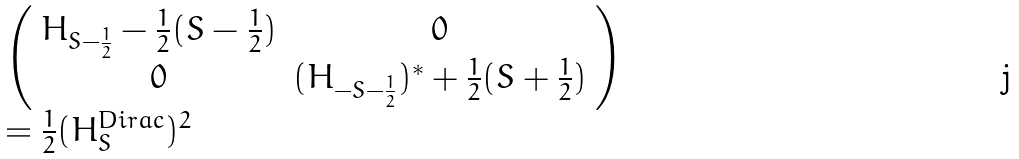<formula> <loc_0><loc_0><loc_500><loc_500>\begin{array} { l } \left ( \begin{array} { c c } H _ { S - \frac { 1 } { 2 } } - \frac { 1 } { 2 } ( S - \frac { 1 } { 2 } ) & 0 \\ 0 & ( H _ { - S - \frac { 1 } { 2 } } ) ^ { * } + \frac { 1 } { 2 } ( S + \frac { 1 } { 2 } ) \end{array} \right ) \ \\ = \frac { 1 } { 2 } ( H ^ { D i r a c } _ { S } ) ^ { 2 } \end{array}</formula> 